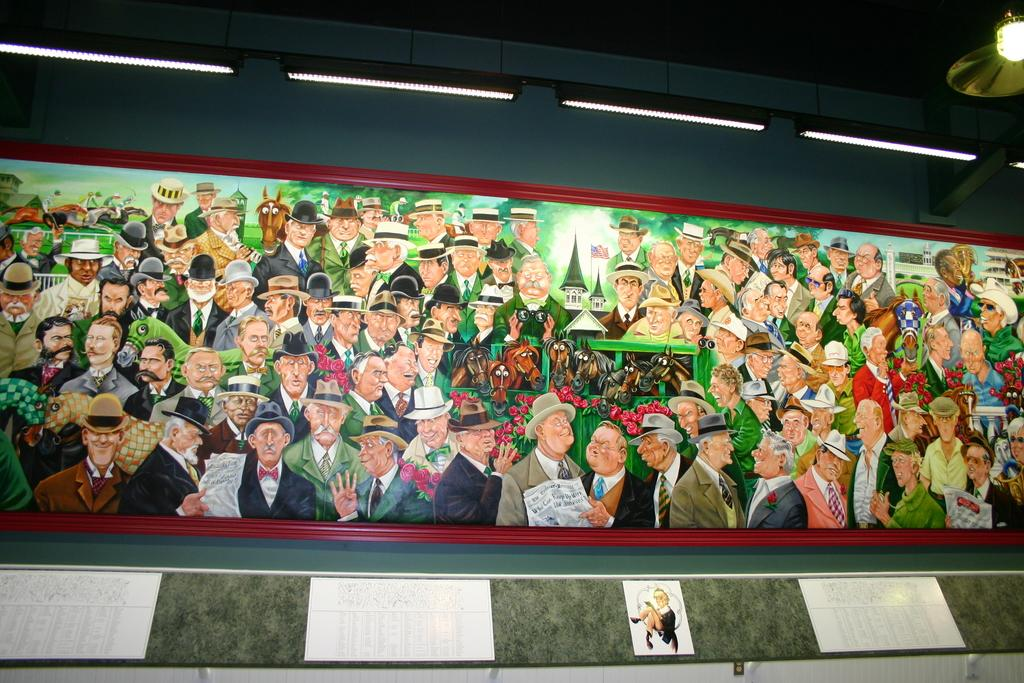What is on the wall in the image? There is a board on the wall in the image. What can be seen on the board? There are people with different color dresses on the board. Are there any accessories worn by the people on the board? Some of the people on the board are wearing hats. What is visible at the top of the board in the image? There are lights visible at the top of the board in the image. What type of advice can be seen written with a crayon on the board in the image? There is no advice written with a crayon on the board in the image. Are there any flowers visible on the board in the image? There are no flowers depicted on the board in the image. 